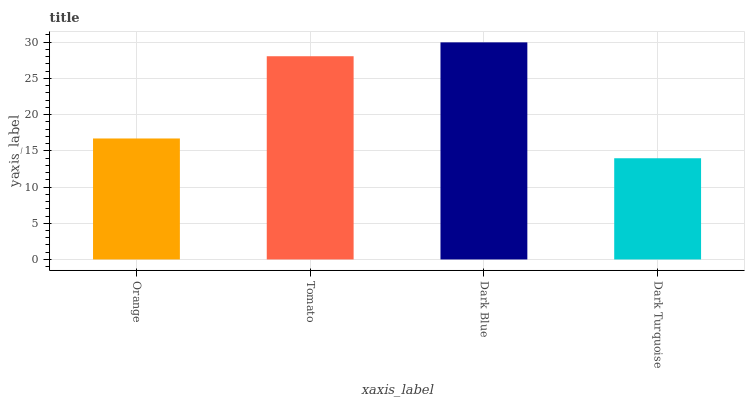Is Dark Turquoise the minimum?
Answer yes or no. Yes. Is Dark Blue the maximum?
Answer yes or no. Yes. Is Tomato the minimum?
Answer yes or no. No. Is Tomato the maximum?
Answer yes or no. No. Is Tomato greater than Orange?
Answer yes or no. Yes. Is Orange less than Tomato?
Answer yes or no. Yes. Is Orange greater than Tomato?
Answer yes or no. No. Is Tomato less than Orange?
Answer yes or no. No. Is Tomato the high median?
Answer yes or no. Yes. Is Orange the low median?
Answer yes or no. Yes. Is Orange the high median?
Answer yes or no. No. Is Dark Turquoise the low median?
Answer yes or no. No. 